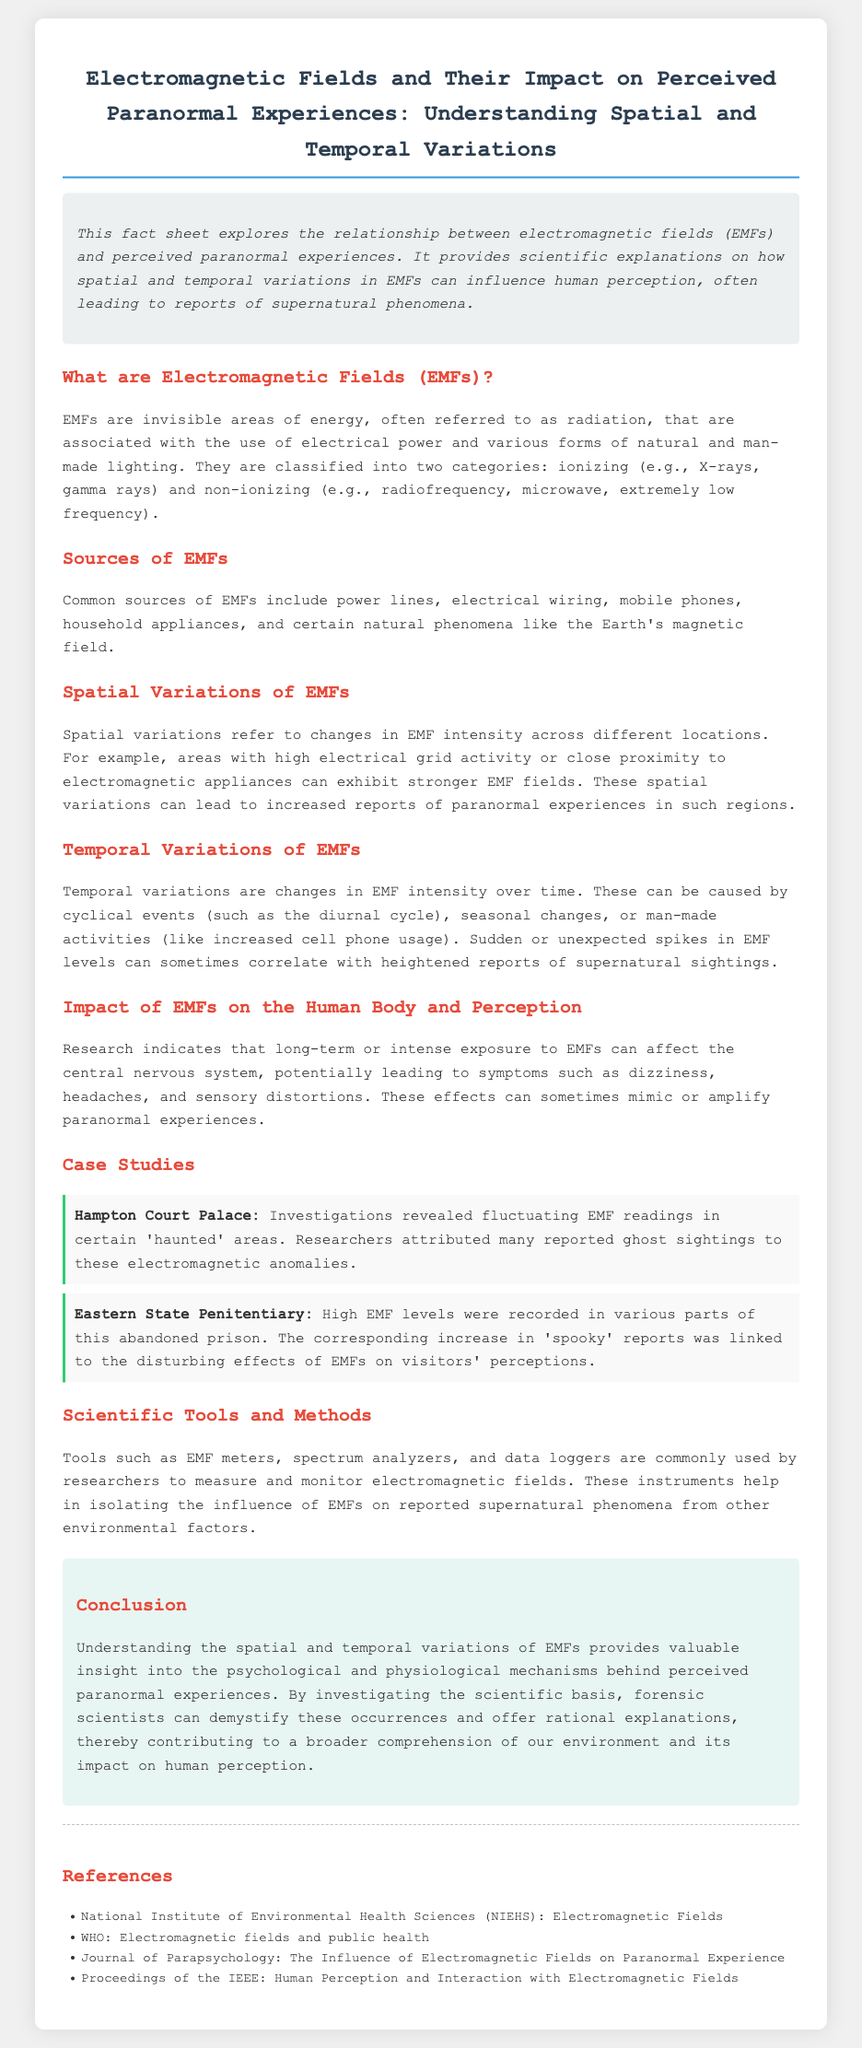What are EMFs? The document defines EMFs as invisible areas of energy, often referred to as radiation, associated with the use of electrical power and various forms of natural and man-made lighting.
Answer: Invisible areas of energy What is one source of EMFs? The document lists common sources of EMFs, such as power lines.
Answer: Power lines What does "spatial variations" refer to? The document explains that spatial variations refer to changes in EMF intensity across different locations.
Answer: Changes in EMF intensity across locations What impacts can EMFs have on the human body? The document mentions several potential impacts on the human body, including dizziness and headaches.
Answer: Dizziness, headaches What case study is mentioned related to a haunted location? The document includes Hampton Court Palace as a case study associated with reported ghost sightings.
Answer: Hampton Court Palace What are tools used to measure EMFs? The document names EMF meters, spectrum analyzers, and data loggers as scientific tools for measuring EMFs.
Answer: EMF meters, spectrum analyzers, data loggers What is the conclusion regarding EMFs and paranormal experiences? The document concludes that understanding EMFs provides insight into psychological and physiological mechanisms behind perceived paranormal experiences.
Answer: Insight into psychological and physiological mechanisms Which organization is referenced for information on electromagnetic fields? The document references the National Institute of Environmental Health Sciences (NIEHS) for information.
Answer: National Institute of Environmental Health Sciences (NIEHS) What type of variations are discussed in relation to EMFs? The document discusses both spatial and temporal variations of EMFs.
Answer: Spatial and temporal variations 